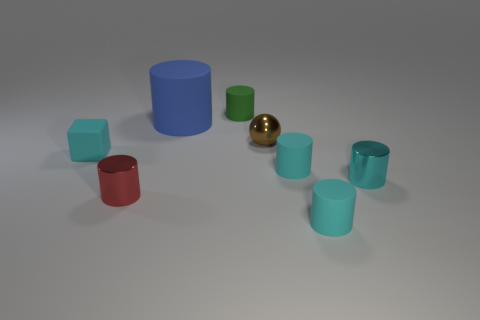There is a thing that is on the right side of the cyan rubber cylinder that is in front of the metal cylinder behind the red thing; what shape is it?
Offer a very short reply. Cylinder. What is the cyan object that is both behind the cyan shiny thing and to the right of the tiny rubber block made of?
Make the answer very short. Rubber. How many other metal things have the same size as the green object?
Offer a very short reply. 3. How many shiny objects are either large purple balls or large blue things?
Ensure brevity in your answer.  0. What material is the tiny green cylinder?
Ensure brevity in your answer.  Rubber. How many cylinders are behind the blue matte cylinder?
Give a very brief answer. 1. Are the cylinder that is behind the blue cylinder and the big blue cylinder made of the same material?
Make the answer very short. Yes. What number of cyan things have the same shape as the blue rubber object?
Your answer should be compact. 3. What number of tiny things are green cylinders or red objects?
Your answer should be very brief. 2. There is a metal cylinder that is on the right side of the big cylinder; does it have the same color as the matte block?
Offer a very short reply. Yes. 